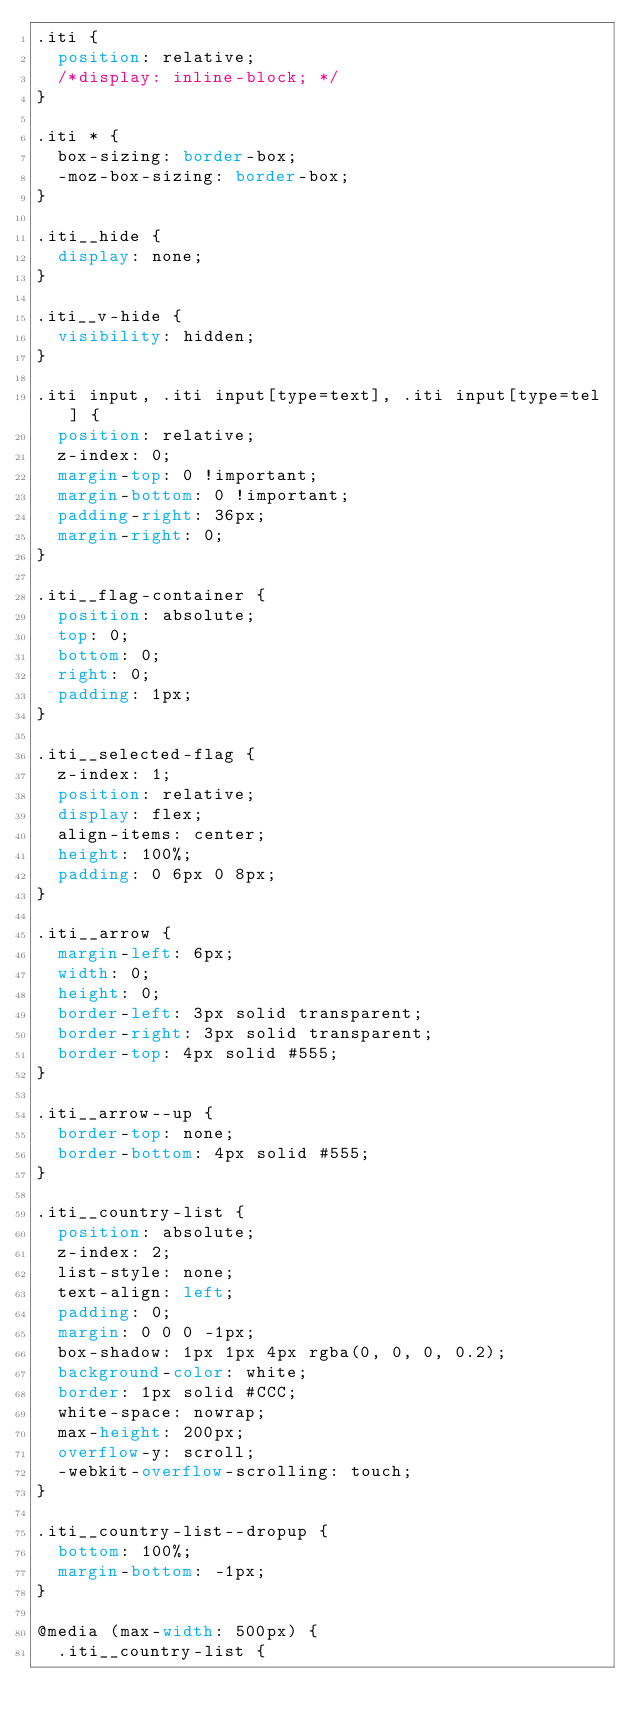<code> <loc_0><loc_0><loc_500><loc_500><_CSS_>.iti {
  position: relative;
  /*display: inline-block; */
}

.iti * {
  box-sizing: border-box;
  -moz-box-sizing: border-box;
}

.iti__hide {
  display: none;
}

.iti__v-hide {
  visibility: hidden;
}

.iti input, .iti input[type=text], .iti input[type=tel] {
  position: relative;
  z-index: 0;
  margin-top: 0 !important;
  margin-bottom: 0 !important;
  padding-right: 36px;
  margin-right: 0;
}

.iti__flag-container {
  position: absolute;
  top: 0;
  bottom: 0;
  right: 0;
  padding: 1px;
}

.iti__selected-flag {
  z-index: 1;
  position: relative;
  display: flex;
  align-items: center;
  height: 100%;
  padding: 0 6px 0 8px;
}

.iti__arrow {
  margin-left: 6px;
  width: 0;
  height: 0;
  border-left: 3px solid transparent;
  border-right: 3px solid transparent;
  border-top: 4px solid #555;
}

.iti__arrow--up {
  border-top: none;
  border-bottom: 4px solid #555;
}

.iti__country-list {
  position: absolute;
  z-index: 2;
  list-style: none;
  text-align: left;
  padding: 0;
  margin: 0 0 0 -1px;
  box-shadow: 1px 1px 4px rgba(0, 0, 0, 0.2);
  background-color: white;
  border: 1px solid #CCC;
  white-space: nowrap;
  max-height: 200px;
  overflow-y: scroll;
  -webkit-overflow-scrolling: touch;
}

.iti__country-list--dropup {
  bottom: 100%;
  margin-bottom: -1px;
}

@media (max-width: 500px) {
  .iti__country-list {</code> 